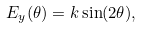Convert formula to latex. <formula><loc_0><loc_0><loc_500><loc_500>E _ { y } ( \theta ) = k \sin ( 2 \theta ) ,</formula> 